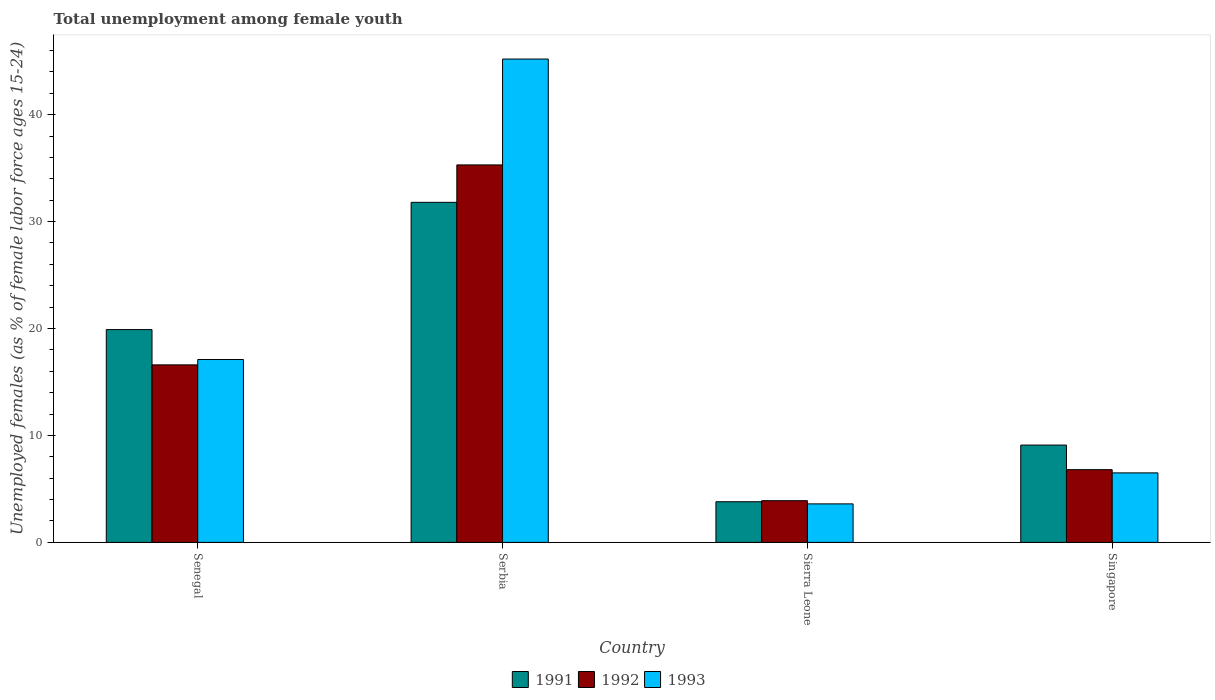How many different coloured bars are there?
Keep it short and to the point. 3. Are the number of bars per tick equal to the number of legend labels?
Your response must be concise. Yes. How many bars are there on the 1st tick from the left?
Give a very brief answer. 3. How many bars are there on the 4th tick from the right?
Your response must be concise. 3. What is the label of the 1st group of bars from the left?
Ensure brevity in your answer.  Senegal. In how many cases, is the number of bars for a given country not equal to the number of legend labels?
Your answer should be very brief. 0. What is the percentage of unemployed females in in 1991 in Senegal?
Ensure brevity in your answer.  19.9. Across all countries, what is the maximum percentage of unemployed females in in 1993?
Ensure brevity in your answer.  45.2. Across all countries, what is the minimum percentage of unemployed females in in 1991?
Offer a very short reply. 3.8. In which country was the percentage of unemployed females in in 1991 maximum?
Ensure brevity in your answer.  Serbia. In which country was the percentage of unemployed females in in 1993 minimum?
Give a very brief answer. Sierra Leone. What is the total percentage of unemployed females in in 1992 in the graph?
Ensure brevity in your answer.  62.6. What is the difference between the percentage of unemployed females in in 1991 in Senegal and that in Singapore?
Offer a very short reply. 10.8. What is the difference between the percentage of unemployed females in in 1992 in Senegal and the percentage of unemployed females in in 1993 in Serbia?
Offer a terse response. -28.6. What is the average percentage of unemployed females in in 1991 per country?
Provide a short and direct response. 16.15. What is the difference between the percentage of unemployed females in of/in 1991 and percentage of unemployed females in of/in 1992 in Serbia?
Your answer should be very brief. -3.5. What is the ratio of the percentage of unemployed females in in 1991 in Serbia to that in Sierra Leone?
Ensure brevity in your answer.  8.37. Is the percentage of unemployed females in in 1993 in Sierra Leone less than that in Singapore?
Your answer should be very brief. Yes. Is the difference between the percentage of unemployed females in in 1991 in Senegal and Singapore greater than the difference between the percentage of unemployed females in in 1992 in Senegal and Singapore?
Offer a terse response. Yes. What is the difference between the highest and the second highest percentage of unemployed females in in 1993?
Keep it short and to the point. -28.1. What is the difference between the highest and the lowest percentage of unemployed females in in 1992?
Offer a terse response. 31.4. In how many countries, is the percentage of unemployed females in in 1991 greater than the average percentage of unemployed females in in 1991 taken over all countries?
Ensure brevity in your answer.  2. What does the 2nd bar from the right in Sierra Leone represents?
Your answer should be very brief. 1992. Are all the bars in the graph horizontal?
Give a very brief answer. No. Does the graph contain grids?
Give a very brief answer. No. What is the title of the graph?
Keep it short and to the point. Total unemployment among female youth. Does "2002" appear as one of the legend labels in the graph?
Your answer should be compact. No. What is the label or title of the X-axis?
Ensure brevity in your answer.  Country. What is the label or title of the Y-axis?
Your response must be concise. Unemployed females (as % of female labor force ages 15-24). What is the Unemployed females (as % of female labor force ages 15-24) of 1991 in Senegal?
Your response must be concise. 19.9. What is the Unemployed females (as % of female labor force ages 15-24) of 1992 in Senegal?
Offer a terse response. 16.6. What is the Unemployed females (as % of female labor force ages 15-24) of 1993 in Senegal?
Ensure brevity in your answer.  17.1. What is the Unemployed females (as % of female labor force ages 15-24) in 1991 in Serbia?
Your answer should be compact. 31.8. What is the Unemployed females (as % of female labor force ages 15-24) in 1992 in Serbia?
Your answer should be very brief. 35.3. What is the Unemployed females (as % of female labor force ages 15-24) in 1993 in Serbia?
Provide a succinct answer. 45.2. What is the Unemployed females (as % of female labor force ages 15-24) in 1991 in Sierra Leone?
Make the answer very short. 3.8. What is the Unemployed females (as % of female labor force ages 15-24) in 1992 in Sierra Leone?
Provide a succinct answer. 3.9. What is the Unemployed females (as % of female labor force ages 15-24) in 1993 in Sierra Leone?
Give a very brief answer. 3.6. What is the Unemployed females (as % of female labor force ages 15-24) in 1991 in Singapore?
Give a very brief answer. 9.1. What is the Unemployed females (as % of female labor force ages 15-24) of 1992 in Singapore?
Offer a very short reply. 6.8. What is the Unemployed females (as % of female labor force ages 15-24) in 1993 in Singapore?
Your response must be concise. 6.5. Across all countries, what is the maximum Unemployed females (as % of female labor force ages 15-24) in 1991?
Your answer should be compact. 31.8. Across all countries, what is the maximum Unemployed females (as % of female labor force ages 15-24) of 1992?
Offer a terse response. 35.3. Across all countries, what is the maximum Unemployed females (as % of female labor force ages 15-24) of 1993?
Offer a very short reply. 45.2. Across all countries, what is the minimum Unemployed females (as % of female labor force ages 15-24) of 1991?
Your response must be concise. 3.8. Across all countries, what is the minimum Unemployed females (as % of female labor force ages 15-24) of 1992?
Offer a terse response. 3.9. Across all countries, what is the minimum Unemployed females (as % of female labor force ages 15-24) of 1993?
Offer a very short reply. 3.6. What is the total Unemployed females (as % of female labor force ages 15-24) in 1991 in the graph?
Your answer should be compact. 64.6. What is the total Unemployed females (as % of female labor force ages 15-24) in 1992 in the graph?
Provide a short and direct response. 62.6. What is the total Unemployed females (as % of female labor force ages 15-24) of 1993 in the graph?
Offer a very short reply. 72.4. What is the difference between the Unemployed females (as % of female labor force ages 15-24) in 1992 in Senegal and that in Serbia?
Make the answer very short. -18.7. What is the difference between the Unemployed females (as % of female labor force ages 15-24) of 1993 in Senegal and that in Serbia?
Offer a very short reply. -28.1. What is the difference between the Unemployed females (as % of female labor force ages 15-24) in 1993 in Senegal and that in Sierra Leone?
Provide a short and direct response. 13.5. What is the difference between the Unemployed females (as % of female labor force ages 15-24) in 1992 in Senegal and that in Singapore?
Your response must be concise. 9.8. What is the difference between the Unemployed females (as % of female labor force ages 15-24) of 1993 in Senegal and that in Singapore?
Ensure brevity in your answer.  10.6. What is the difference between the Unemployed females (as % of female labor force ages 15-24) of 1991 in Serbia and that in Sierra Leone?
Give a very brief answer. 28. What is the difference between the Unemployed females (as % of female labor force ages 15-24) of 1992 in Serbia and that in Sierra Leone?
Offer a terse response. 31.4. What is the difference between the Unemployed females (as % of female labor force ages 15-24) of 1993 in Serbia and that in Sierra Leone?
Provide a succinct answer. 41.6. What is the difference between the Unemployed females (as % of female labor force ages 15-24) of 1991 in Serbia and that in Singapore?
Make the answer very short. 22.7. What is the difference between the Unemployed females (as % of female labor force ages 15-24) of 1992 in Serbia and that in Singapore?
Make the answer very short. 28.5. What is the difference between the Unemployed females (as % of female labor force ages 15-24) in 1993 in Serbia and that in Singapore?
Provide a short and direct response. 38.7. What is the difference between the Unemployed females (as % of female labor force ages 15-24) in 1991 in Sierra Leone and that in Singapore?
Ensure brevity in your answer.  -5.3. What is the difference between the Unemployed females (as % of female labor force ages 15-24) of 1992 in Sierra Leone and that in Singapore?
Keep it short and to the point. -2.9. What is the difference between the Unemployed females (as % of female labor force ages 15-24) of 1993 in Sierra Leone and that in Singapore?
Ensure brevity in your answer.  -2.9. What is the difference between the Unemployed females (as % of female labor force ages 15-24) of 1991 in Senegal and the Unemployed females (as % of female labor force ages 15-24) of 1992 in Serbia?
Keep it short and to the point. -15.4. What is the difference between the Unemployed females (as % of female labor force ages 15-24) in 1991 in Senegal and the Unemployed females (as % of female labor force ages 15-24) in 1993 in Serbia?
Give a very brief answer. -25.3. What is the difference between the Unemployed females (as % of female labor force ages 15-24) of 1992 in Senegal and the Unemployed females (as % of female labor force ages 15-24) of 1993 in Serbia?
Keep it short and to the point. -28.6. What is the difference between the Unemployed females (as % of female labor force ages 15-24) of 1991 in Senegal and the Unemployed females (as % of female labor force ages 15-24) of 1992 in Sierra Leone?
Offer a terse response. 16. What is the difference between the Unemployed females (as % of female labor force ages 15-24) of 1991 in Senegal and the Unemployed females (as % of female labor force ages 15-24) of 1993 in Sierra Leone?
Make the answer very short. 16.3. What is the difference between the Unemployed females (as % of female labor force ages 15-24) in 1992 in Senegal and the Unemployed females (as % of female labor force ages 15-24) in 1993 in Sierra Leone?
Your response must be concise. 13. What is the difference between the Unemployed females (as % of female labor force ages 15-24) of 1991 in Serbia and the Unemployed females (as % of female labor force ages 15-24) of 1992 in Sierra Leone?
Offer a terse response. 27.9. What is the difference between the Unemployed females (as % of female labor force ages 15-24) in 1991 in Serbia and the Unemployed females (as % of female labor force ages 15-24) in 1993 in Sierra Leone?
Provide a short and direct response. 28.2. What is the difference between the Unemployed females (as % of female labor force ages 15-24) of 1992 in Serbia and the Unemployed females (as % of female labor force ages 15-24) of 1993 in Sierra Leone?
Ensure brevity in your answer.  31.7. What is the difference between the Unemployed females (as % of female labor force ages 15-24) in 1991 in Serbia and the Unemployed females (as % of female labor force ages 15-24) in 1992 in Singapore?
Your answer should be very brief. 25. What is the difference between the Unemployed females (as % of female labor force ages 15-24) of 1991 in Serbia and the Unemployed females (as % of female labor force ages 15-24) of 1993 in Singapore?
Your response must be concise. 25.3. What is the difference between the Unemployed females (as % of female labor force ages 15-24) in 1992 in Serbia and the Unemployed females (as % of female labor force ages 15-24) in 1993 in Singapore?
Provide a short and direct response. 28.8. What is the difference between the Unemployed females (as % of female labor force ages 15-24) of 1991 in Sierra Leone and the Unemployed females (as % of female labor force ages 15-24) of 1993 in Singapore?
Provide a short and direct response. -2.7. What is the difference between the Unemployed females (as % of female labor force ages 15-24) of 1992 in Sierra Leone and the Unemployed females (as % of female labor force ages 15-24) of 1993 in Singapore?
Provide a succinct answer. -2.6. What is the average Unemployed females (as % of female labor force ages 15-24) of 1991 per country?
Provide a succinct answer. 16.15. What is the average Unemployed females (as % of female labor force ages 15-24) of 1992 per country?
Your answer should be very brief. 15.65. What is the average Unemployed females (as % of female labor force ages 15-24) in 1993 per country?
Offer a terse response. 18.1. What is the difference between the Unemployed females (as % of female labor force ages 15-24) of 1992 and Unemployed females (as % of female labor force ages 15-24) of 1993 in Senegal?
Give a very brief answer. -0.5. What is the difference between the Unemployed females (as % of female labor force ages 15-24) in 1991 and Unemployed females (as % of female labor force ages 15-24) in 1992 in Serbia?
Make the answer very short. -3.5. What is the difference between the Unemployed females (as % of female labor force ages 15-24) of 1991 and Unemployed females (as % of female labor force ages 15-24) of 1993 in Serbia?
Offer a terse response. -13.4. What is the difference between the Unemployed females (as % of female labor force ages 15-24) of 1992 and Unemployed females (as % of female labor force ages 15-24) of 1993 in Serbia?
Provide a short and direct response. -9.9. What is the difference between the Unemployed females (as % of female labor force ages 15-24) of 1991 and Unemployed females (as % of female labor force ages 15-24) of 1993 in Sierra Leone?
Your answer should be compact. 0.2. What is the difference between the Unemployed females (as % of female labor force ages 15-24) of 1991 and Unemployed females (as % of female labor force ages 15-24) of 1992 in Singapore?
Provide a short and direct response. 2.3. What is the difference between the Unemployed females (as % of female labor force ages 15-24) of 1992 and Unemployed females (as % of female labor force ages 15-24) of 1993 in Singapore?
Keep it short and to the point. 0.3. What is the ratio of the Unemployed females (as % of female labor force ages 15-24) of 1991 in Senegal to that in Serbia?
Make the answer very short. 0.63. What is the ratio of the Unemployed females (as % of female labor force ages 15-24) in 1992 in Senegal to that in Serbia?
Your response must be concise. 0.47. What is the ratio of the Unemployed females (as % of female labor force ages 15-24) of 1993 in Senegal to that in Serbia?
Give a very brief answer. 0.38. What is the ratio of the Unemployed females (as % of female labor force ages 15-24) of 1991 in Senegal to that in Sierra Leone?
Your answer should be compact. 5.24. What is the ratio of the Unemployed females (as % of female labor force ages 15-24) of 1992 in Senegal to that in Sierra Leone?
Provide a short and direct response. 4.26. What is the ratio of the Unemployed females (as % of female labor force ages 15-24) of 1993 in Senegal to that in Sierra Leone?
Give a very brief answer. 4.75. What is the ratio of the Unemployed females (as % of female labor force ages 15-24) in 1991 in Senegal to that in Singapore?
Keep it short and to the point. 2.19. What is the ratio of the Unemployed females (as % of female labor force ages 15-24) in 1992 in Senegal to that in Singapore?
Give a very brief answer. 2.44. What is the ratio of the Unemployed females (as % of female labor force ages 15-24) in 1993 in Senegal to that in Singapore?
Your response must be concise. 2.63. What is the ratio of the Unemployed females (as % of female labor force ages 15-24) in 1991 in Serbia to that in Sierra Leone?
Give a very brief answer. 8.37. What is the ratio of the Unemployed females (as % of female labor force ages 15-24) in 1992 in Serbia to that in Sierra Leone?
Give a very brief answer. 9.05. What is the ratio of the Unemployed females (as % of female labor force ages 15-24) in 1993 in Serbia to that in Sierra Leone?
Your answer should be very brief. 12.56. What is the ratio of the Unemployed females (as % of female labor force ages 15-24) of 1991 in Serbia to that in Singapore?
Your response must be concise. 3.49. What is the ratio of the Unemployed females (as % of female labor force ages 15-24) in 1992 in Serbia to that in Singapore?
Keep it short and to the point. 5.19. What is the ratio of the Unemployed females (as % of female labor force ages 15-24) of 1993 in Serbia to that in Singapore?
Your response must be concise. 6.95. What is the ratio of the Unemployed females (as % of female labor force ages 15-24) of 1991 in Sierra Leone to that in Singapore?
Your answer should be compact. 0.42. What is the ratio of the Unemployed females (as % of female labor force ages 15-24) in 1992 in Sierra Leone to that in Singapore?
Offer a very short reply. 0.57. What is the ratio of the Unemployed females (as % of female labor force ages 15-24) in 1993 in Sierra Leone to that in Singapore?
Provide a short and direct response. 0.55. What is the difference between the highest and the second highest Unemployed females (as % of female labor force ages 15-24) in 1991?
Provide a succinct answer. 11.9. What is the difference between the highest and the second highest Unemployed females (as % of female labor force ages 15-24) of 1992?
Make the answer very short. 18.7. What is the difference between the highest and the second highest Unemployed females (as % of female labor force ages 15-24) in 1993?
Your answer should be very brief. 28.1. What is the difference between the highest and the lowest Unemployed females (as % of female labor force ages 15-24) of 1992?
Your answer should be compact. 31.4. What is the difference between the highest and the lowest Unemployed females (as % of female labor force ages 15-24) in 1993?
Your response must be concise. 41.6. 